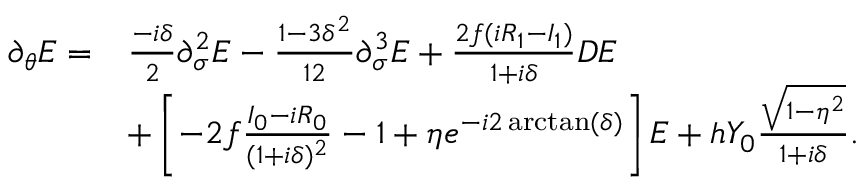<formula> <loc_0><loc_0><loc_500><loc_500>\begin{array} { r l } { \partial _ { \theta } E = } & { \frac { - i \delta } { 2 } \partial _ { \sigma } ^ { 2 } E - \frac { 1 - 3 \delta ^ { 2 } } { 1 2 } \partial _ { \sigma } ^ { 3 } E + \frac { 2 f ( i R _ { 1 } - I _ { 1 } ) } { 1 + i \delta } D E } \\ & { + \left [ - 2 f \frac { I _ { 0 } - i R _ { 0 } } { ( 1 + i \delta ) ^ { 2 } } - 1 + \eta e ^ { - i 2 \arctan ( \delta ) } \right ] E + h Y _ { 0 } \frac { \sqrt { 1 - \eta ^ { 2 } } } { 1 + i \delta } . } \end{array}</formula> 